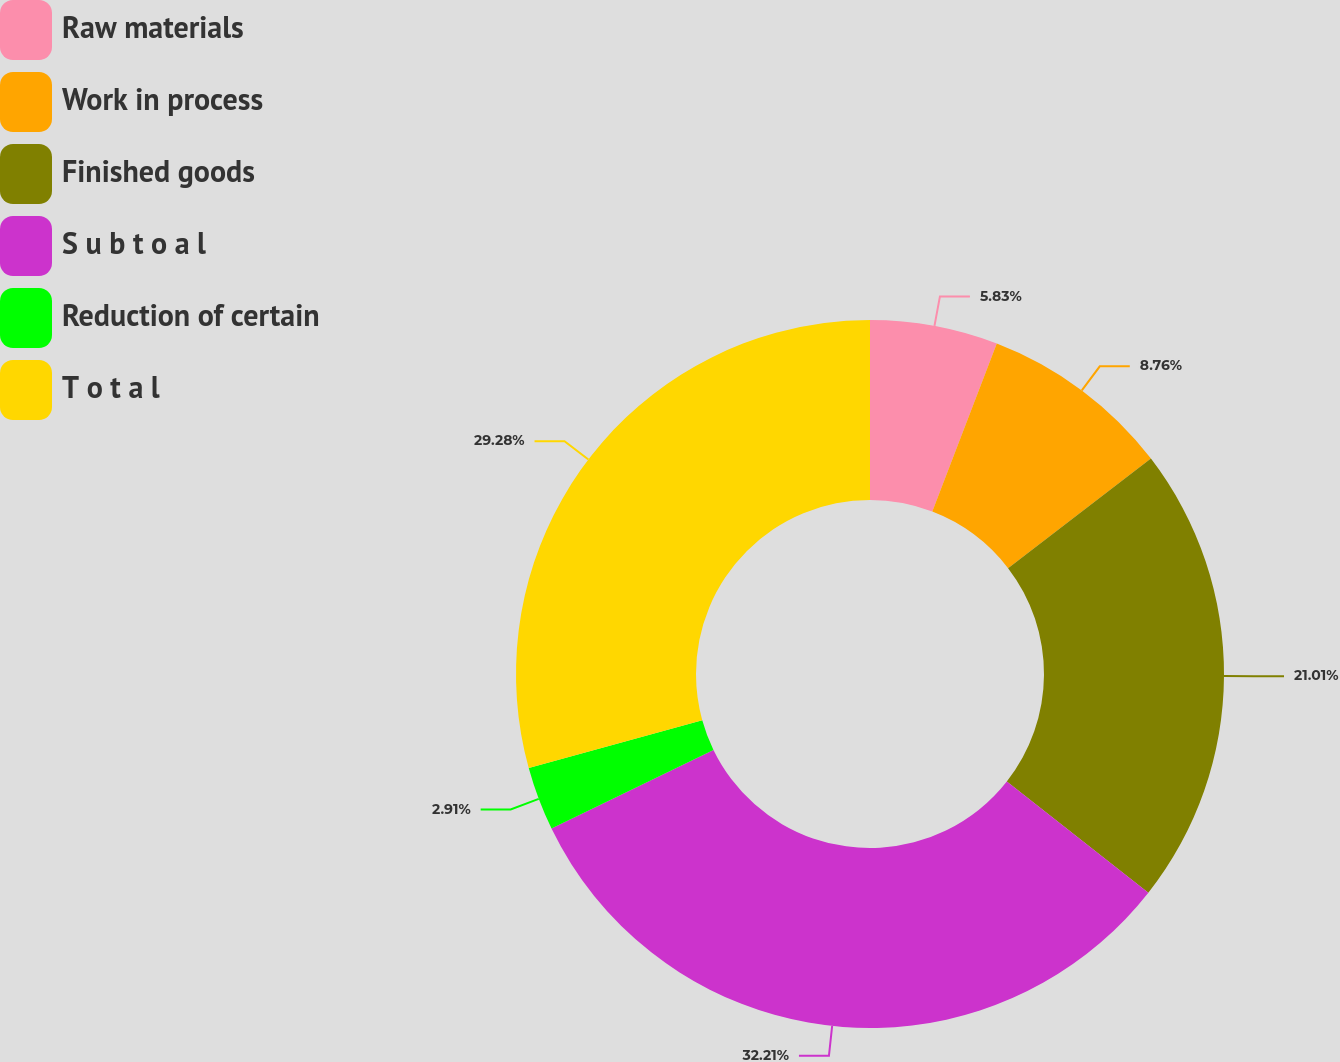Convert chart to OTSL. <chart><loc_0><loc_0><loc_500><loc_500><pie_chart><fcel>Raw materials<fcel>Work in process<fcel>Finished goods<fcel>S u b t o a l<fcel>Reduction of certain<fcel>T o t a l<nl><fcel>5.83%<fcel>8.76%<fcel>21.01%<fcel>32.21%<fcel>2.91%<fcel>29.28%<nl></chart> 